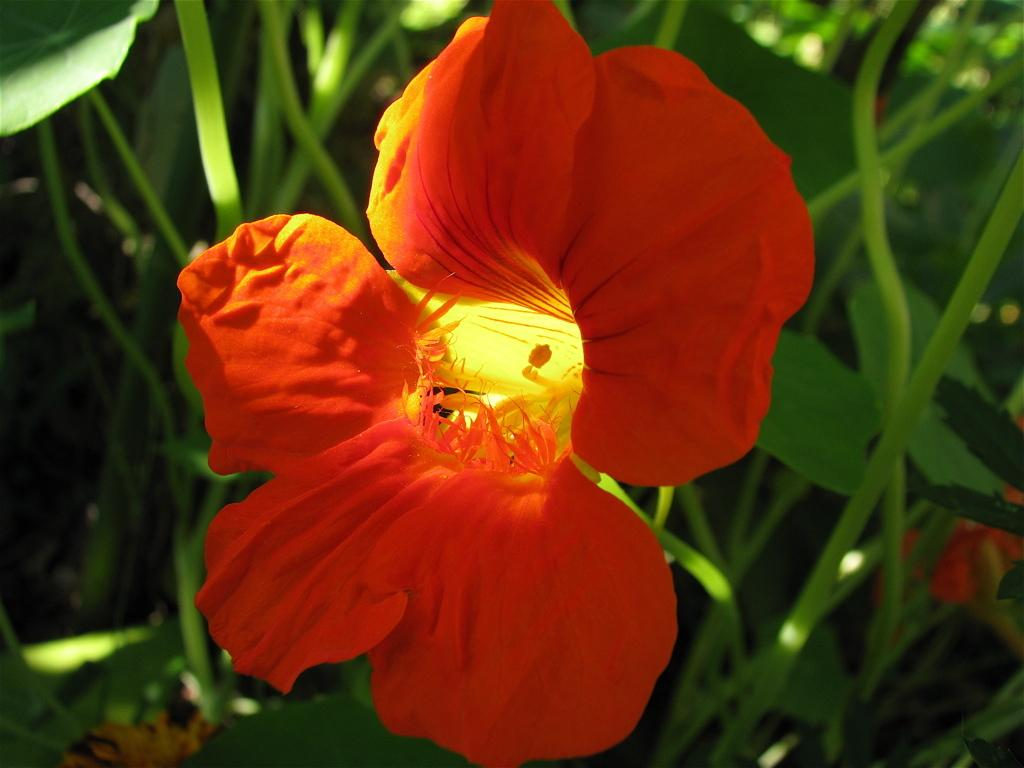What is present in the image? There are flowers in the image. Where are the flowers located? The flowers are on plants. What color are the flowers? The flowers are red in color. What type of liquid can be smelled coming from the flowers in the image? There is no mention of a scent or liquid in the image; it only shows red flowers on plants. 